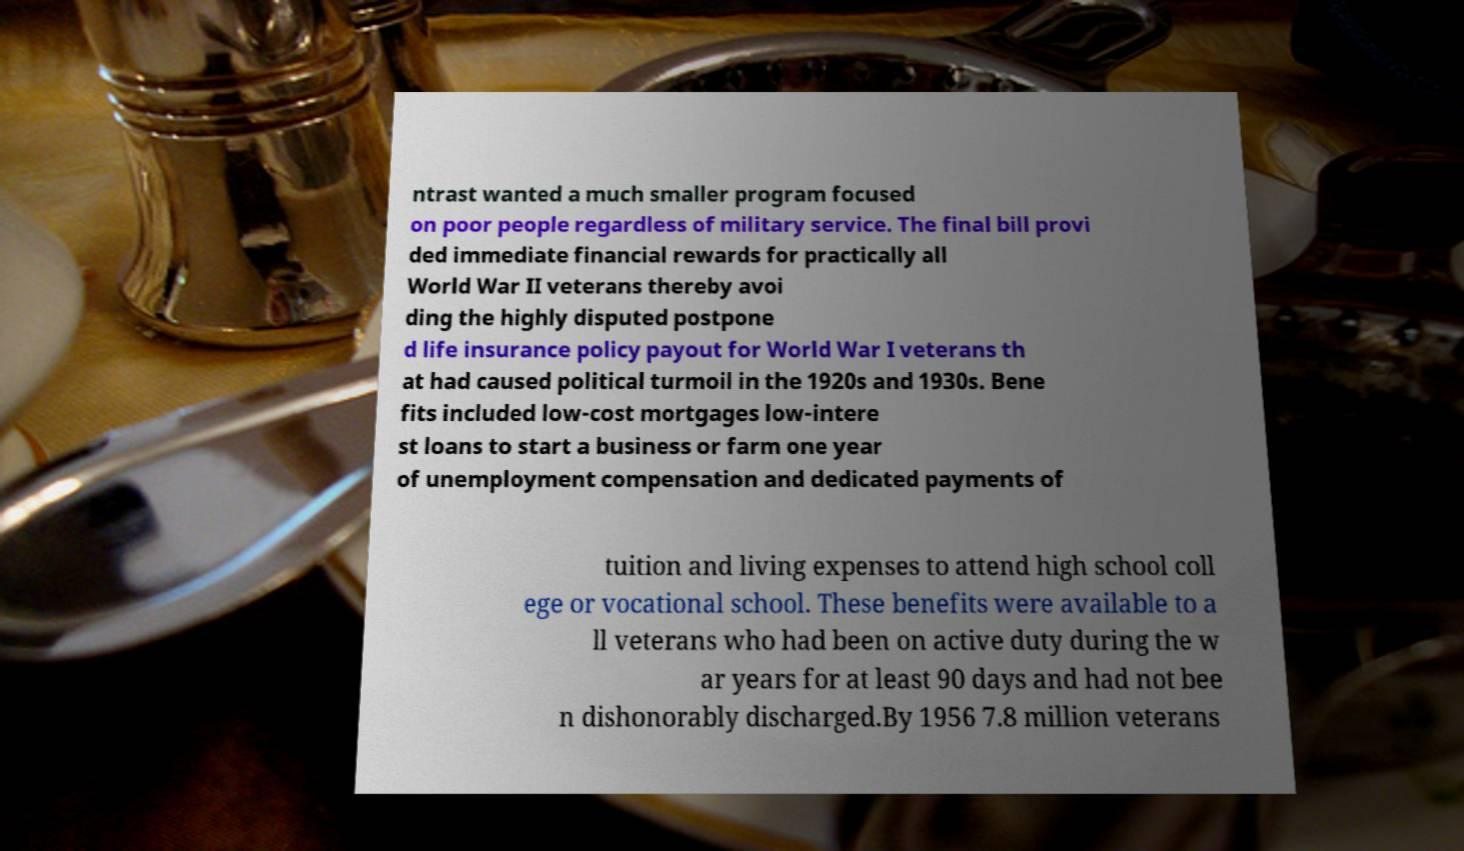Can you read and provide the text displayed in the image?This photo seems to have some interesting text. Can you extract and type it out for me? ntrast wanted a much smaller program focused on poor people regardless of military service. The final bill provi ded immediate financial rewards for practically all World War II veterans thereby avoi ding the highly disputed postpone d life insurance policy payout for World War I veterans th at had caused political turmoil in the 1920s and 1930s. Bene fits included low-cost mortgages low-intere st loans to start a business or farm one year of unemployment compensation and dedicated payments of tuition and living expenses to attend high school coll ege or vocational school. These benefits were available to a ll veterans who had been on active duty during the w ar years for at least 90 days and had not bee n dishonorably discharged.By 1956 7.8 million veterans 